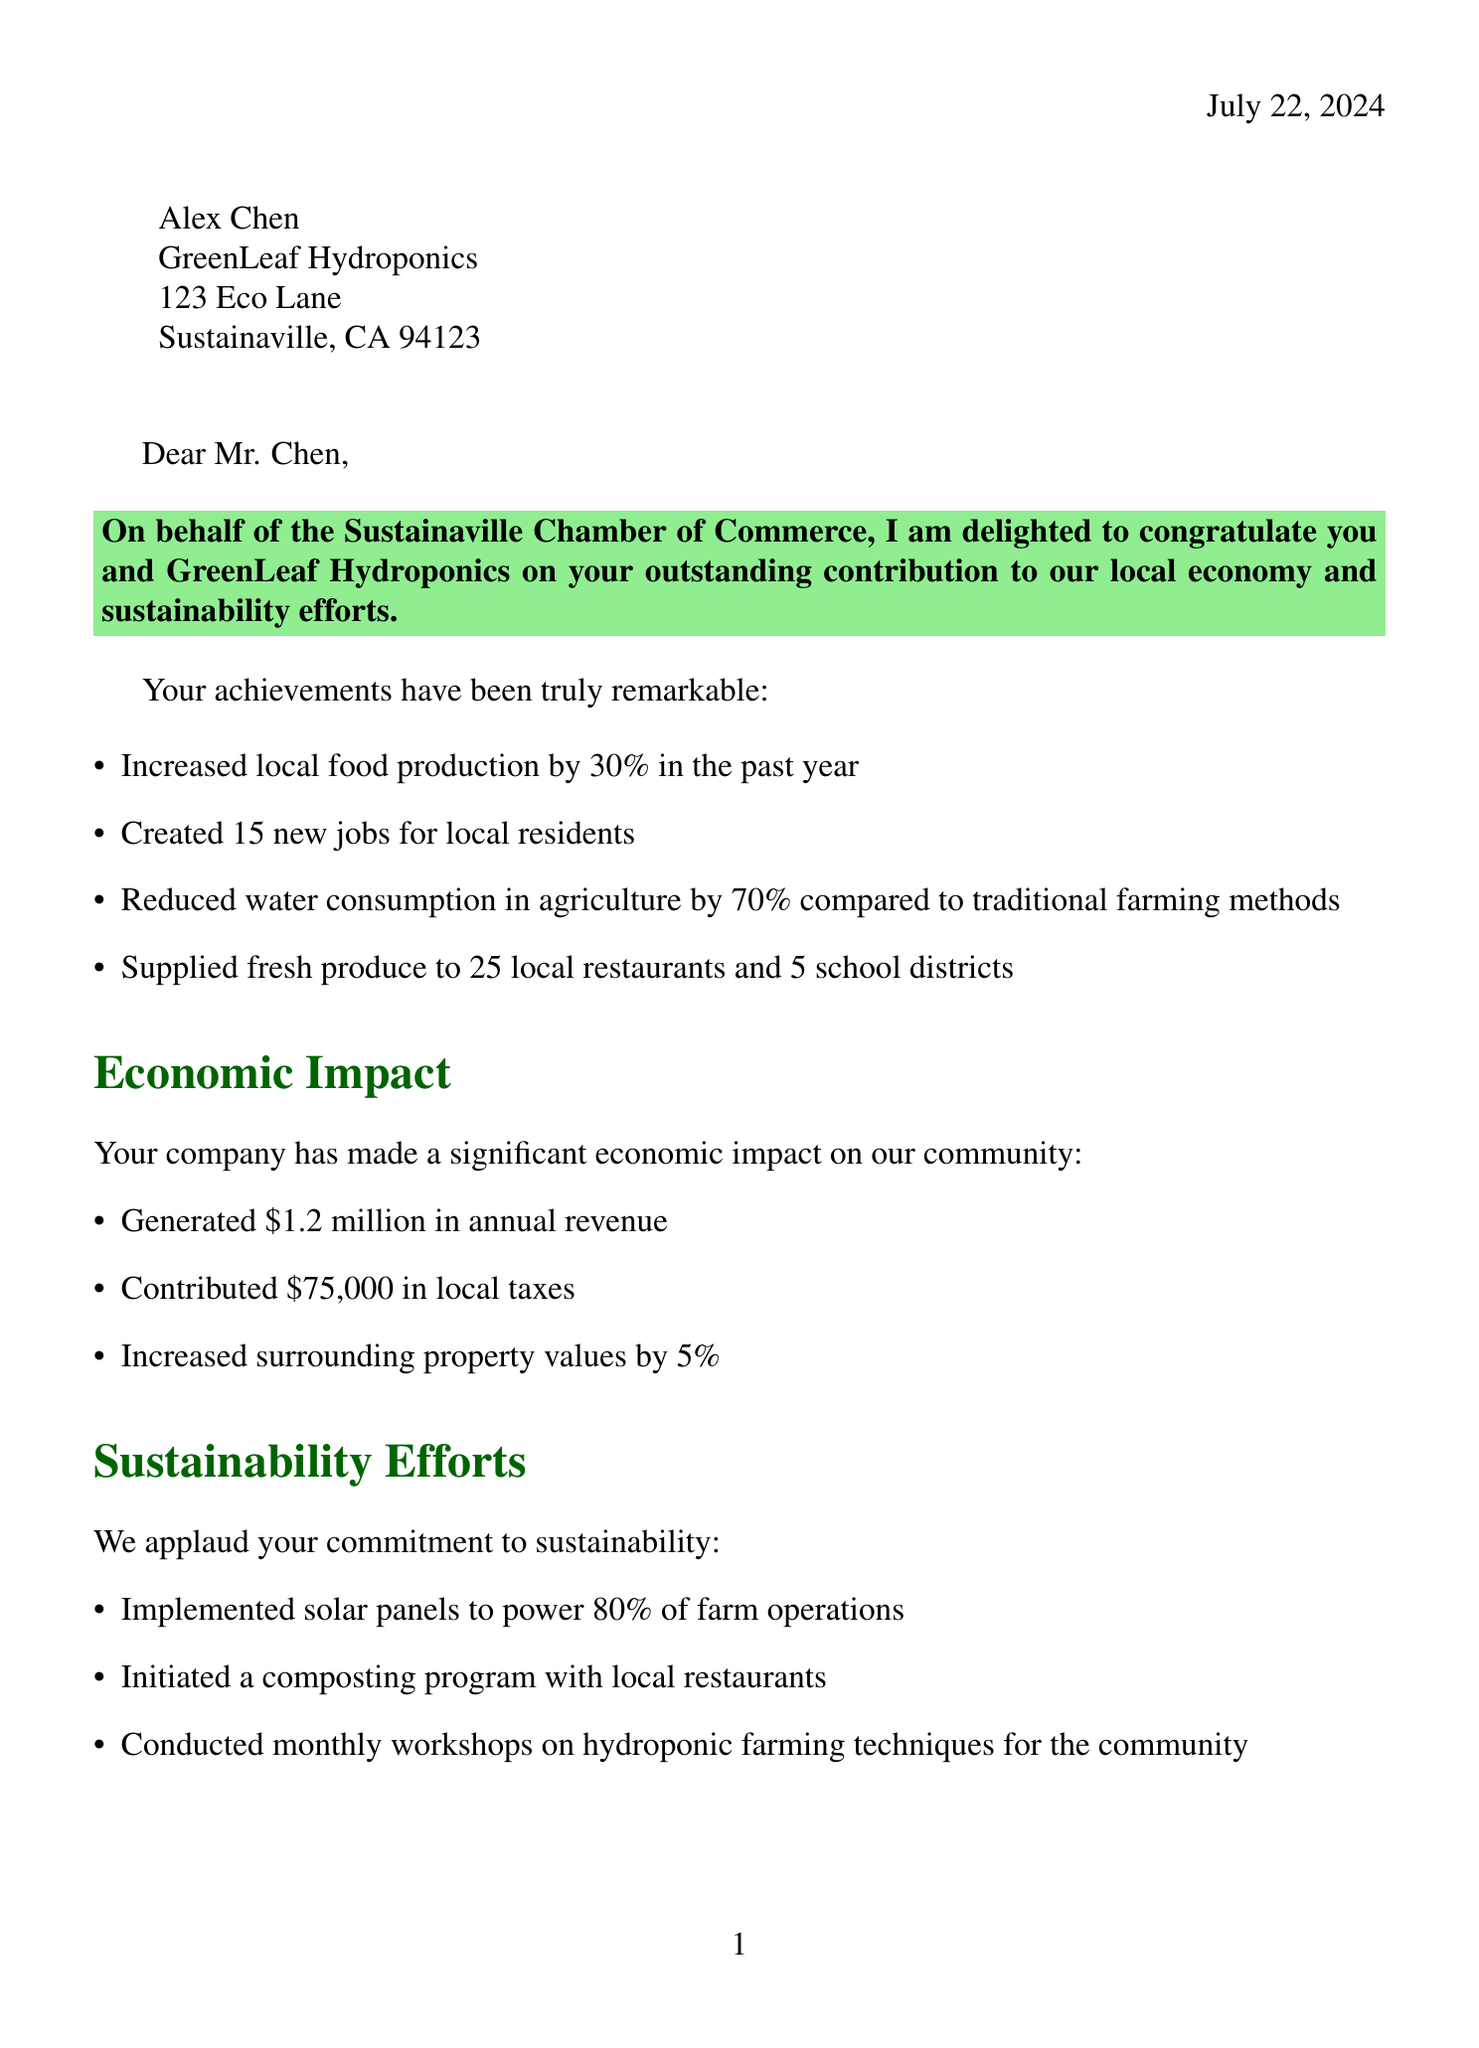What is the name of the recipient? The recipient's name is clearly stated at the beginning of the letter.
Answer: Alex Chen What is the address of GreenLeaf Hydroponics? The address is provided in the recipient's section of the document.
Answer: 123 Eco Lane, Sustainaville, CA 94123 How many new jobs were created? This information is listed under the achievements section of the letter.
Answer: 15 What is the percentage increase in local food production? The percentage increase is specified in the achievements section of the letter.
Answer: 30% What is the award received by GreenLeaf Hydroponics? This is mentioned in the recognition section of the letter.
Answer: Sustainaville Green Business of the Year When is the Annual Chamber of Commerce Gala? The date is explicitly stated in the recognition section of the letter.
Answer: September 15, 2023 What percentage of farm operations is powered by solar panels? This information is included in the sustainability efforts section.
Answer: 80% What is the annual revenue generated by GreenLeaf Hydroponics? The revenue is specified in the economic impact section of the letter.
Answer: $1.2 million What community college is partnered with GreenLeaf Hydroponics? The partnership is mentioned in the community involvement section of the document.
Answer: Sustainaville Community College 